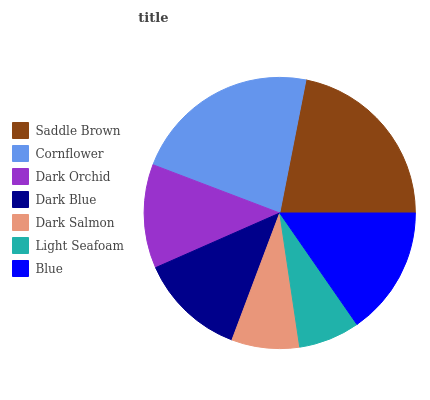Is Light Seafoam the minimum?
Answer yes or no. Yes. Is Cornflower the maximum?
Answer yes or no. Yes. Is Dark Orchid the minimum?
Answer yes or no. No. Is Dark Orchid the maximum?
Answer yes or no. No. Is Cornflower greater than Dark Orchid?
Answer yes or no. Yes. Is Dark Orchid less than Cornflower?
Answer yes or no. Yes. Is Dark Orchid greater than Cornflower?
Answer yes or no. No. Is Cornflower less than Dark Orchid?
Answer yes or no. No. Is Dark Blue the high median?
Answer yes or no. Yes. Is Dark Blue the low median?
Answer yes or no. Yes. Is Blue the high median?
Answer yes or no. No. Is Dark Orchid the low median?
Answer yes or no. No. 